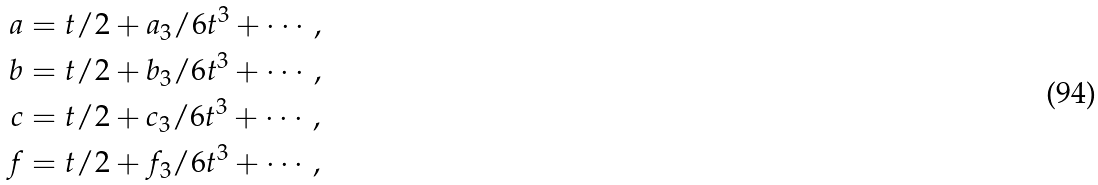<formula> <loc_0><loc_0><loc_500><loc_500>a & = t / 2 + a _ { 3 } / 6 t ^ { 3 } + \cdots , \\ b & = t / 2 + b _ { 3 } / 6 t ^ { 3 } + \cdots , \\ c & = t / 2 + c _ { 3 } / 6 t ^ { 3 } + \cdots , \\ f & = t / 2 + f _ { 3 } / 6 t ^ { 3 } + \cdots , \\</formula> 